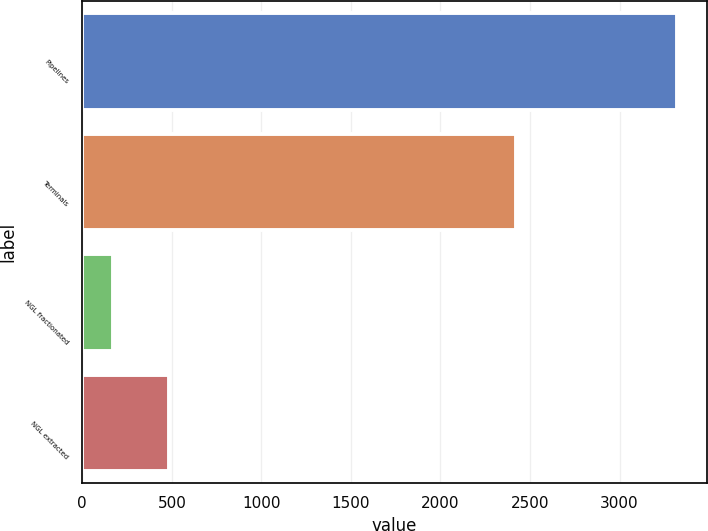Convert chart to OTSL. <chart><loc_0><loc_0><loc_500><loc_500><bar_chart><fcel>Pipelines<fcel>Terminals<fcel>NGL fractionated<fcel>NGL extracted<nl><fcel>3321<fcel>2422<fcel>170<fcel>485.1<nl></chart> 